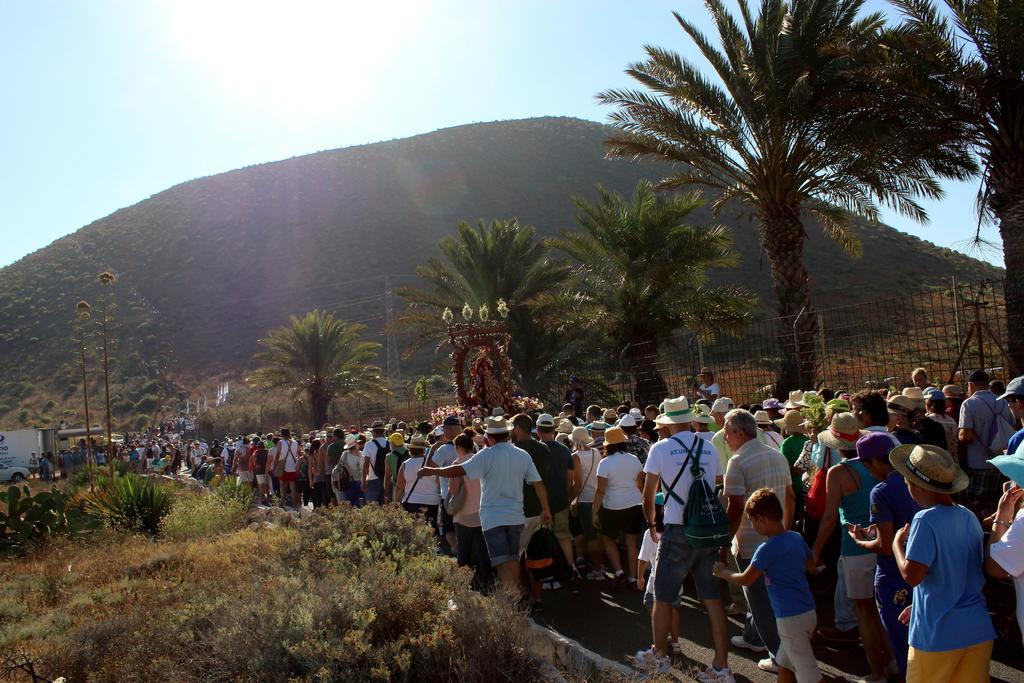Could you give a brief overview of what you see in this image? On the left side of the image there is grass on the ground and also there are small plants. Beside them there are many people with hats on their heads. Beside them there is fencing. Behind the fencing there are trees. In the background there is a car and also there is room. And also there is a hill with trees. At the top of the image there is sky with sun. 